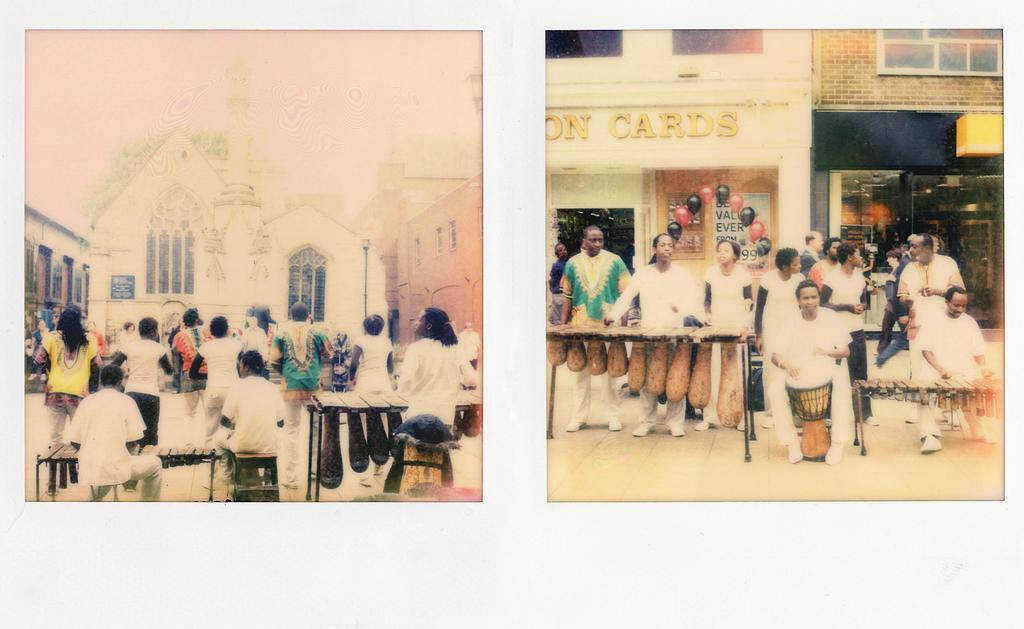Describe this image in one or two sentences. It is the photo collage, on the left side few people are sitting, they wore white color t-shirts. In the middle few people are dancing and there is a building in white color. On the right side a group of people are standing, behind them there are balloons to the doors and there are buildings. 